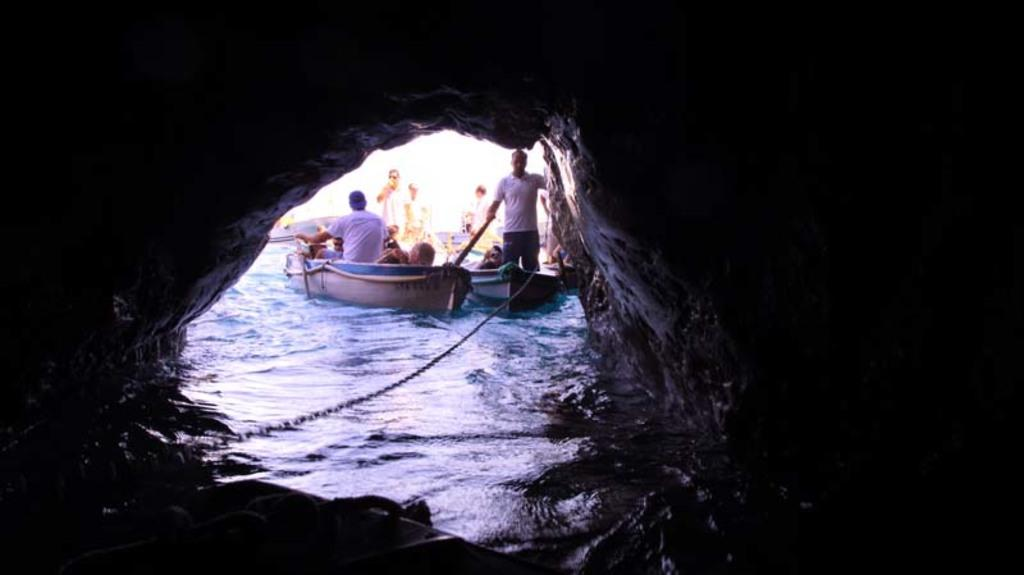What are the persons in the image doing? The persons in the image are standing and sitting in two boats. Where are the boats located in relation to the cave? The boats are near a cave. What can be seen in the background of the image? The sky is visible in the background of the image. What type of meal is being prepared in the cave in the image? There is no indication of a meal being prepared in the cave in the image. 